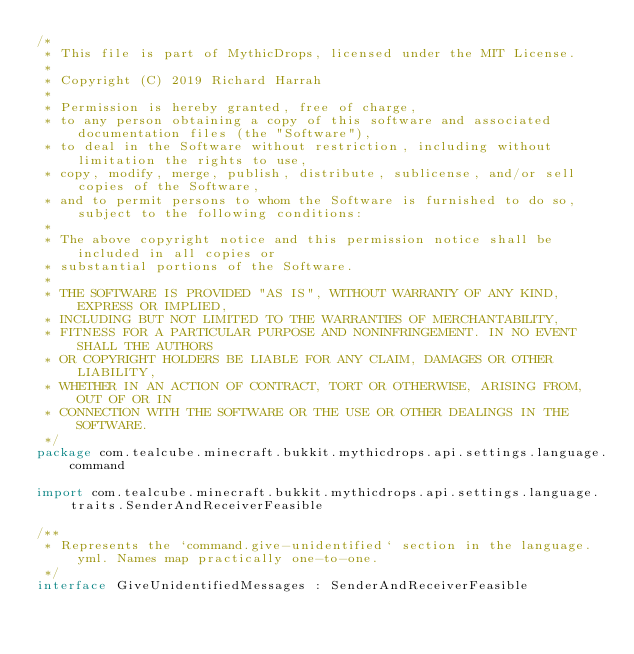Convert code to text. <code><loc_0><loc_0><loc_500><loc_500><_Kotlin_>/*
 * This file is part of MythicDrops, licensed under the MIT License.
 *
 * Copyright (C) 2019 Richard Harrah
 *
 * Permission is hereby granted, free of charge,
 * to any person obtaining a copy of this software and associated documentation files (the "Software"),
 * to deal in the Software without restriction, including without limitation the rights to use,
 * copy, modify, merge, publish, distribute, sublicense, and/or sell copies of the Software,
 * and to permit persons to whom the Software is furnished to do so, subject to the following conditions:
 *
 * The above copyright notice and this permission notice shall be included in all copies or
 * substantial portions of the Software.
 *
 * THE SOFTWARE IS PROVIDED "AS IS", WITHOUT WARRANTY OF ANY KIND, EXPRESS OR IMPLIED,
 * INCLUDING BUT NOT LIMITED TO THE WARRANTIES OF MERCHANTABILITY,
 * FITNESS FOR A PARTICULAR PURPOSE AND NONINFRINGEMENT. IN NO EVENT SHALL THE AUTHORS
 * OR COPYRIGHT HOLDERS BE LIABLE FOR ANY CLAIM, DAMAGES OR OTHER LIABILITY,
 * WHETHER IN AN ACTION OF CONTRACT, TORT OR OTHERWISE, ARISING FROM, OUT OF OR IN
 * CONNECTION WITH THE SOFTWARE OR THE USE OR OTHER DEALINGS IN THE SOFTWARE.
 */
package com.tealcube.minecraft.bukkit.mythicdrops.api.settings.language.command

import com.tealcube.minecraft.bukkit.mythicdrops.api.settings.language.traits.SenderAndReceiverFeasible

/**
 * Represents the `command.give-unidentified` section in the language.yml. Names map practically one-to-one.
 */
interface GiveUnidentifiedMessages : SenderAndReceiverFeasible
</code> 